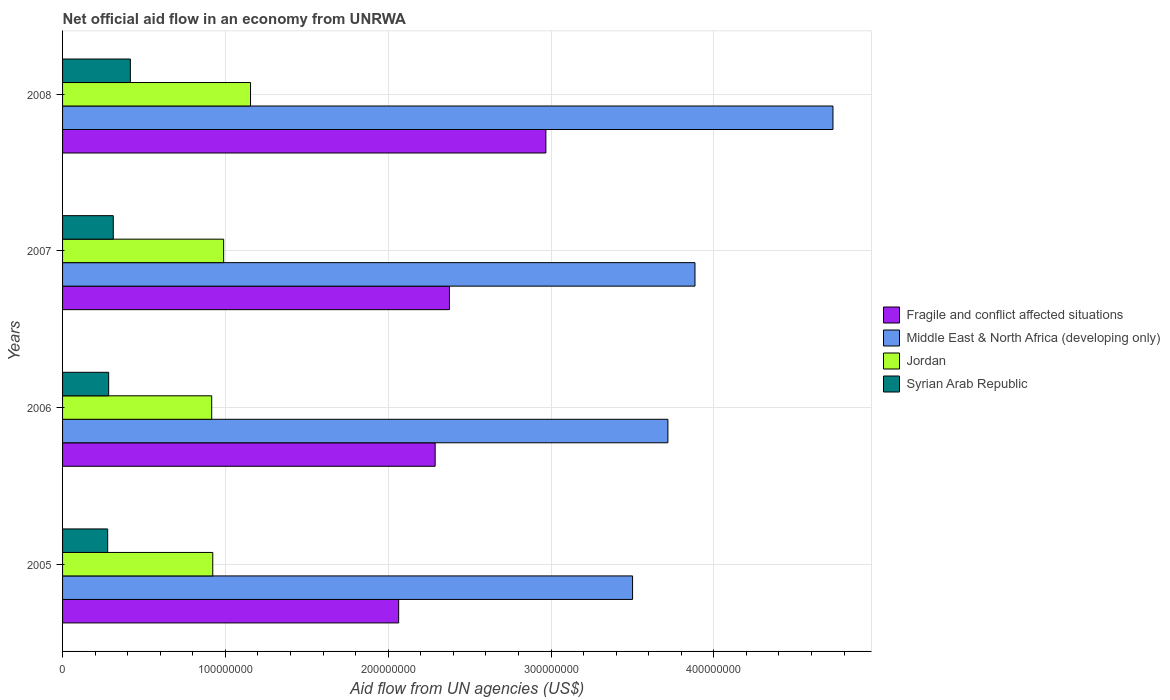How many different coloured bars are there?
Keep it short and to the point. 4. How many groups of bars are there?
Provide a succinct answer. 4. How many bars are there on the 2nd tick from the top?
Ensure brevity in your answer.  4. In how many cases, is the number of bars for a given year not equal to the number of legend labels?
Offer a terse response. 0. What is the net official aid flow in Jordan in 2006?
Give a very brief answer. 9.16e+07. Across all years, what is the maximum net official aid flow in Middle East & North Africa (developing only)?
Offer a terse response. 4.73e+08. Across all years, what is the minimum net official aid flow in Middle East & North Africa (developing only)?
Your answer should be compact. 3.50e+08. What is the total net official aid flow in Jordan in the graph?
Provide a succinct answer. 3.98e+08. What is the difference between the net official aid flow in Syrian Arab Republic in 2006 and that in 2007?
Your response must be concise. -2.83e+06. What is the difference between the net official aid flow in Syrian Arab Republic in 2005 and the net official aid flow in Middle East & North Africa (developing only) in 2007?
Ensure brevity in your answer.  -3.61e+08. What is the average net official aid flow in Syrian Arab Republic per year?
Offer a terse response. 3.22e+07. In the year 2008, what is the difference between the net official aid flow in Syrian Arab Republic and net official aid flow in Jordan?
Your response must be concise. -7.38e+07. In how many years, is the net official aid flow in Syrian Arab Republic greater than 140000000 US$?
Offer a very short reply. 0. What is the ratio of the net official aid flow in Fragile and conflict affected situations in 2007 to that in 2008?
Provide a short and direct response. 0.8. Is the difference between the net official aid flow in Syrian Arab Republic in 2005 and 2006 greater than the difference between the net official aid flow in Jordan in 2005 and 2006?
Keep it short and to the point. No. What is the difference between the highest and the second highest net official aid flow in Middle East & North Africa (developing only)?
Give a very brief answer. 8.48e+07. What is the difference between the highest and the lowest net official aid flow in Fragile and conflict affected situations?
Your answer should be compact. 9.04e+07. What does the 3rd bar from the top in 2005 represents?
Keep it short and to the point. Middle East & North Africa (developing only). What does the 2nd bar from the bottom in 2006 represents?
Make the answer very short. Middle East & North Africa (developing only). Are all the bars in the graph horizontal?
Provide a short and direct response. Yes. How many years are there in the graph?
Your answer should be very brief. 4. Are the values on the major ticks of X-axis written in scientific E-notation?
Your answer should be very brief. No. Does the graph contain any zero values?
Ensure brevity in your answer.  No. How many legend labels are there?
Provide a succinct answer. 4. What is the title of the graph?
Give a very brief answer. Net official aid flow in an economy from UNRWA. What is the label or title of the X-axis?
Provide a succinct answer. Aid flow from UN agencies (US$). What is the label or title of the Y-axis?
Provide a short and direct response. Years. What is the Aid flow from UN agencies (US$) in Fragile and conflict affected situations in 2005?
Offer a very short reply. 2.06e+08. What is the Aid flow from UN agencies (US$) of Middle East & North Africa (developing only) in 2005?
Give a very brief answer. 3.50e+08. What is the Aid flow from UN agencies (US$) in Jordan in 2005?
Offer a very short reply. 9.22e+07. What is the Aid flow from UN agencies (US$) of Syrian Arab Republic in 2005?
Give a very brief answer. 2.77e+07. What is the Aid flow from UN agencies (US$) of Fragile and conflict affected situations in 2006?
Provide a short and direct response. 2.29e+08. What is the Aid flow from UN agencies (US$) in Middle East & North Africa (developing only) in 2006?
Ensure brevity in your answer.  3.72e+08. What is the Aid flow from UN agencies (US$) of Jordan in 2006?
Your answer should be compact. 9.16e+07. What is the Aid flow from UN agencies (US$) in Syrian Arab Republic in 2006?
Keep it short and to the point. 2.83e+07. What is the Aid flow from UN agencies (US$) of Fragile and conflict affected situations in 2007?
Offer a terse response. 2.38e+08. What is the Aid flow from UN agencies (US$) in Middle East & North Africa (developing only) in 2007?
Provide a succinct answer. 3.88e+08. What is the Aid flow from UN agencies (US$) in Jordan in 2007?
Provide a short and direct response. 9.89e+07. What is the Aid flow from UN agencies (US$) of Syrian Arab Republic in 2007?
Make the answer very short. 3.12e+07. What is the Aid flow from UN agencies (US$) in Fragile and conflict affected situations in 2008?
Keep it short and to the point. 2.97e+08. What is the Aid flow from UN agencies (US$) of Middle East & North Africa (developing only) in 2008?
Offer a very short reply. 4.73e+08. What is the Aid flow from UN agencies (US$) of Jordan in 2008?
Give a very brief answer. 1.15e+08. What is the Aid flow from UN agencies (US$) in Syrian Arab Republic in 2008?
Your answer should be compact. 4.16e+07. Across all years, what is the maximum Aid flow from UN agencies (US$) of Fragile and conflict affected situations?
Your answer should be compact. 2.97e+08. Across all years, what is the maximum Aid flow from UN agencies (US$) in Middle East & North Africa (developing only)?
Keep it short and to the point. 4.73e+08. Across all years, what is the maximum Aid flow from UN agencies (US$) in Jordan?
Provide a short and direct response. 1.15e+08. Across all years, what is the maximum Aid flow from UN agencies (US$) of Syrian Arab Republic?
Your answer should be compact. 4.16e+07. Across all years, what is the minimum Aid flow from UN agencies (US$) in Fragile and conflict affected situations?
Keep it short and to the point. 2.06e+08. Across all years, what is the minimum Aid flow from UN agencies (US$) in Middle East & North Africa (developing only)?
Keep it short and to the point. 3.50e+08. Across all years, what is the minimum Aid flow from UN agencies (US$) of Jordan?
Offer a terse response. 9.16e+07. Across all years, what is the minimum Aid flow from UN agencies (US$) in Syrian Arab Republic?
Your response must be concise. 2.77e+07. What is the total Aid flow from UN agencies (US$) of Fragile and conflict affected situations in the graph?
Provide a succinct answer. 9.70e+08. What is the total Aid flow from UN agencies (US$) in Middle East & North Africa (developing only) in the graph?
Offer a very short reply. 1.58e+09. What is the total Aid flow from UN agencies (US$) in Jordan in the graph?
Offer a very short reply. 3.98e+08. What is the total Aid flow from UN agencies (US$) in Syrian Arab Republic in the graph?
Your response must be concise. 1.29e+08. What is the difference between the Aid flow from UN agencies (US$) of Fragile and conflict affected situations in 2005 and that in 2006?
Make the answer very short. -2.24e+07. What is the difference between the Aid flow from UN agencies (US$) of Middle East & North Africa (developing only) in 2005 and that in 2006?
Offer a very short reply. -2.17e+07. What is the difference between the Aid flow from UN agencies (US$) of Jordan in 2005 and that in 2006?
Give a very brief answer. 6.50e+05. What is the difference between the Aid flow from UN agencies (US$) in Syrian Arab Republic in 2005 and that in 2006?
Your response must be concise. -6.10e+05. What is the difference between the Aid flow from UN agencies (US$) of Fragile and conflict affected situations in 2005 and that in 2007?
Ensure brevity in your answer.  -3.12e+07. What is the difference between the Aid flow from UN agencies (US$) of Middle East & North Africa (developing only) in 2005 and that in 2007?
Your answer should be compact. -3.83e+07. What is the difference between the Aid flow from UN agencies (US$) in Jordan in 2005 and that in 2007?
Offer a terse response. -6.68e+06. What is the difference between the Aid flow from UN agencies (US$) in Syrian Arab Republic in 2005 and that in 2007?
Your answer should be very brief. -3.44e+06. What is the difference between the Aid flow from UN agencies (US$) in Fragile and conflict affected situations in 2005 and that in 2008?
Give a very brief answer. -9.04e+07. What is the difference between the Aid flow from UN agencies (US$) of Middle East & North Africa (developing only) in 2005 and that in 2008?
Offer a very short reply. -1.23e+08. What is the difference between the Aid flow from UN agencies (US$) of Jordan in 2005 and that in 2008?
Ensure brevity in your answer.  -2.32e+07. What is the difference between the Aid flow from UN agencies (US$) in Syrian Arab Republic in 2005 and that in 2008?
Provide a short and direct response. -1.39e+07. What is the difference between the Aid flow from UN agencies (US$) of Fragile and conflict affected situations in 2006 and that in 2007?
Offer a terse response. -8.77e+06. What is the difference between the Aid flow from UN agencies (US$) of Middle East & North Africa (developing only) in 2006 and that in 2007?
Ensure brevity in your answer.  -1.66e+07. What is the difference between the Aid flow from UN agencies (US$) in Jordan in 2006 and that in 2007?
Give a very brief answer. -7.33e+06. What is the difference between the Aid flow from UN agencies (US$) of Syrian Arab Republic in 2006 and that in 2007?
Your answer should be very brief. -2.83e+06. What is the difference between the Aid flow from UN agencies (US$) in Fragile and conflict affected situations in 2006 and that in 2008?
Your answer should be very brief. -6.80e+07. What is the difference between the Aid flow from UN agencies (US$) of Middle East & North Africa (developing only) in 2006 and that in 2008?
Offer a very short reply. -1.01e+08. What is the difference between the Aid flow from UN agencies (US$) in Jordan in 2006 and that in 2008?
Offer a very short reply. -2.38e+07. What is the difference between the Aid flow from UN agencies (US$) of Syrian Arab Republic in 2006 and that in 2008?
Keep it short and to the point. -1.33e+07. What is the difference between the Aid flow from UN agencies (US$) in Fragile and conflict affected situations in 2007 and that in 2008?
Your answer should be very brief. -5.92e+07. What is the difference between the Aid flow from UN agencies (US$) in Middle East & North Africa (developing only) in 2007 and that in 2008?
Your answer should be compact. -8.48e+07. What is the difference between the Aid flow from UN agencies (US$) of Jordan in 2007 and that in 2008?
Your answer should be compact. -1.65e+07. What is the difference between the Aid flow from UN agencies (US$) in Syrian Arab Republic in 2007 and that in 2008?
Offer a very short reply. -1.05e+07. What is the difference between the Aid flow from UN agencies (US$) of Fragile and conflict affected situations in 2005 and the Aid flow from UN agencies (US$) of Middle East & North Africa (developing only) in 2006?
Your response must be concise. -1.65e+08. What is the difference between the Aid flow from UN agencies (US$) in Fragile and conflict affected situations in 2005 and the Aid flow from UN agencies (US$) in Jordan in 2006?
Your response must be concise. 1.15e+08. What is the difference between the Aid flow from UN agencies (US$) of Fragile and conflict affected situations in 2005 and the Aid flow from UN agencies (US$) of Syrian Arab Republic in 2006?
Make the answer very short. 1.78e+08. What is the difference between the Aid flow from UN agencies (US$) in Middle East & North Africa (developing only) in 2005 and the Aid flow from UN agencies (US$) in Jordan in 2006?
Keep it short and to the point. 2.59e+08. What is the difference between the Aid flow from UN agencies (US$) of Middle East & North Africa (developing only) in 2005 and the Aid flow from UN agencies (US$) of Syrian Arab Republic in 2006?
Your response must be concise. 3.22e+08. What is the difference between the Aid flow from UN agencies (US$) in Jordan in 2005 and the Aid flow from UN agencies (US$) in Syrian Arab Republic in 2006?
Your answer should be compact. 6.39e+07. What is the difference between the Aid flow from UN agencies (US$) of Fragile and conflict affected situations in 2005 and the Aid flow from UN agencies (US$) of Middle East & North Africa (developing only) in 2007?
Provide a short and direct response. -1.82e+08. What is the difference between the Aid flow from UN agencies (US$) of Fragile and conflict affected situations in 2005 and the Aid flow from UN agencies (US$) of Jordan in 2007?
Offer a very short reply. 1.08e+08. What is the difference between the Aid flow from UN agencies (US$) in Fragile and conflict affected situations in 2005 and the Aid flow from UN agencies (US$) in Syrian Arab Republic in 2007?
Your response must be concise. 1.75e+08. What is the difference between the Aid flow from UN agencies (US$) of Middle East & North Africa (developing only) in 2005 and the Aid flow from UN agencies (US$) of Jordan in 2007?
Your answer should be very brief. 2.51e+08. What is the difference between the Aid flow from UN agencies (US$) of Middle East & North Africa (developing only) in 2005 and the Aid flow from UN agencies (US$) of Syrian Arab Republic in 2007?
Offer a very short reply. 3.19e+08. What is the difference between the Aid flow from UN agencies (US$) in Jordan in 2005 and the Aid flow from UN agencies (US$) in Syrian Arab Republic in 2007?
Provide a short and direct response. 6.11e+07. What is the difference between the Aid flow from UN agencies (US$) of Fragile and conflict affected situations in 2005 and the Aid flow from UN agencies (US$) of Middle East & North Africa (developing only) in 2008?
Your answer should be very brief. -2.67e+08. What is the difference between the Aid flow from UN agencies (US$) in Fragile and conflict affected situations in 2005 and the Aid flow from UN agencies (US$) in Jordan in 2008?
Your response must be concise. 9.10e+07. What is the difference between the Aid flow from UN agencies (US$) of Fragile and conflict affected situations in 2005 and the Aid flow from UN agencies (US$) of Syrian Arab Republic in 2008?
Your response must be concise. 1.65e+08. What is the difference between the Aid flow from UN agencies (US$) in Middle East & North Africa (developing only) in 2005 and the Aid flow from UN agencies (US$) in Jordan in 2008?
Your answer should be very brief. 2.35e+08. What is the difference between the Aid flow from UN agencies (US$) of Middle East & North Africa (developing only) in 2005 and the Aid flow from UN agencies (US$) of Syrian Arab Republic in 2008?
Keep it short and to the point. 3.08e+08. What is the difference between the Aid flow from UN agencies (US$) of Jordan in 2005 and the Aid flow from UN agencies (US$) of Syrian Arab Republic in 2008?
Ensure brevity in your answer.  5.06e+07. What is the difference between the Aid flow from UN agencies (US$) in Fragile and conflict affected situations in 2006 and the Aid flow from UN agencies (US$) in Middle East & North Africa (developing only) in 2007?
Offer a terse response. -1.60e+08. What is the difference between the Aid flow from UN agencies (US$) of Fragile and conflict affected situations in 2006 and the Aid flow from UN agencies (US$) of Jordan in 2007?
Make the answer very short. 1.30e+08. What is the difference between the Aid flow from UN agencies (US$) in Fragile and conflict affected situations in 2006 and the Aid flow from UN agencies (US$) in Syrian Arab Republic in 2007?
Make the answer very short. 1.98e+08. What is the difference between the Aid flow from UN agencies (US$) of Middle East & North Africa (developing only) in 2006 and the Aid flow from UN agencies (US$) of Jordan in 2007?
Your answer should be very brief. 2.73e+08. What is the difference between the Aid flow from UN agencies (US$) of Middle East & North Africa (developing only) in 2006 and the Aid flow from UN agencies (US$) of Syrian Arab Republic in 2007?
Your response must be concise. 3.41e+08. What is the difference between the Aid flow from UN agencies (US$) of Jordan in 2006 and the Aid flow from UN agencies (US$) of Syrian Arab Republic in 2007?
Provide a succinct answer. 6.04e+07. What is the difference between the Aid flow from UN agencies (US$) in Fragile and conflict affected situations in 2006 and the Aid flow from UN agencies (US$) in Middle East & North Africa (developing only) in 2008?
Offer a very short reply. -2.44e+08. What is the difference between the Aid flow from UN agencies (US$) of Fragile and conflict affected situations in 2006 and the Aid flow from UN agencies (US$) of Jordan in 2008?
Offer a terse response. 1.13e+08. What is the difference between the Aid flow from UN agencies (US$) in Fragile and conflict affected situations in 2006 and the Aid flow from UN agencies (US$) in Syrian Arab Republic in 2008?
Give a very brief answer. 1.87e+08. What is the difference between the Aid flow from UN agencies (US$) of Middle East & North Africa (developing only) in 2006 and the Aid flow from UN agencies (US$) of Jordan in 2008?
Give a very brief answer. 2.56e+08. What is the difference between the Aid flow from UN agencies (US$) in Middle East & North Africa (developing only) in 2006 and the Aid flow from UN agencies (US$) in Syrian Arab Republic in 2008?
Keep it short and to the point. 3.30e+08. What is the difference between the Aid flow from UN agencies (US$) of Jordan in 2006 and the Aid flow from UN agencies (US$) of Syrian Arab Republic in 2008?
Your response must be concise. 5.00e+07. What is the difference between the Aid flow from UN agencies (US$) of Fragile and conflict affected situations in 2007 and the Aid flow from UN agencies (US$) of Middle East & North Africa (developing only) in 2008?
Keep it short and to the point. -2.36e+08. What is the difference between the Aid flow from UN agencies (US$) of Fragile and conflict affected situations in 2007 and the Aid flow from UN agencies (US$) of Jordan in 2008?
Make the answer very short. 1.22e+08. What is the difference between the Aid flow from UN agencies (US$) of Fragile and conflict affected situations in 2007 and the Aid flow from UN agencies (US$) of Syrian Arab Republic in 2008?
Offer a terse response. 1.96e+08. What is the difference between the Aid flow from UN agencies (US$) in Middle East & North Africa (developing only) in 2007 and the Aid flow from UN agencies (US$) in Jordan in 2008?
Your answer should be compact. 2.73e+08. What is the difference between the Aid flow from UN agencies (US$) in Middle East & North Africa (developing only) in 2007 and the Aid flow from UN agencies (US$) in Syrian Arab Republic in 2008?
Ensure brevity in your answer.  3.47e+08. What is the difference between the Aid flow from UN agencies (US$) in Jordan in 2007 and the Aid flow from UN agencies (US$) in Syrian Arab Republic in 2008?
Your response must be concise. 5.73e+07. What is the average Aid flow from UN agencies (US$) of Fragile and conflict affected situations per year?
Ensure brevity in your answer.  2.42e+08. What is the average Aid flow from UN agencies (US$) of Middle East & North Africa (developing only) per year?
Offer a terse response. 3.96e+08. What is the average Aid flow from UN agencies (US$) of Jordan per year?
Give a very brief answer. 9.96e+07. What is the average Aid flow from UN agencies (US$) in Syrian Arab Republic per year?
Give a very brief answer. 3.22e+07. In the year 2005, what is the difference between the Aid flow from UN agencies (US$) of Fragile and conflict affected situations and Aid flow from UN agencies (US$) of Middle East & North Africa (developing only)?
Provide a succinct answer. -1.44e+08. In the year 2005, what is the difference between the Aid flow from UN agencies (US$) of Fragile and conflict affected situations and Aid flow from UN agencies (US$) of Jordan?
Your response must be concise. 1.14e+08. In the year 2005, what is the difference between the Aid flow from UN agencies (US$) in Fragile and conflict affected situations and Aid flow from UN agencies (US$) in Syrian Arab Republic?
Offer a very short reply. 1.79e+08. In the year 2005, what is the difference between the Aid flow from UN agencies (US$) in Middle East & North Africa (developing only) and Aid flow from UN agencies (US$) in Jordan?
Give a very brief answer. 2.58e+08. In the year 2005, what is the difference between the Aid flow from UN agencies (US$) in Middle East & North Africa (developing only) and Aid flow from UN agencies (US$) in Syrian Arab Republic?
Make the answer very short. 3.22e+08. In the year 2005, what is the difference between the Aid flow from UN agencies (US$) in Jordan and Aid flow from UN agencies (US$) in Syrian Arab Republic?
Your response must be concise. 6.45e+07. In the year 2006, what is the difference between the Aid flow from UN agencies (US$) in Fragile and conflict affected situations and Aid flow from UN agencies (US$) in Middle East & North Africa (developing only)?
Make the answer very short. -1.43e+08. In the year 2006, what is the difference between the Aid flow from UN agencies (US$) of Fragile and conflict affected situations and Aid flow from UN agencies (US$) of Jordan?
Keep it short and to the point. 1.37e+08. In the year 2006, what is the difference between the Aid flow from UN agencies (US$) in Fragile and conflict affected situations and Aid flow from UN agencies (US$) in Syrian Arab Republic?
Give a very brief answer. 2.01e+08. In the year 2006, what is the difference between the Aid flow from UN agencies (US$) of Middle East & North Africa (developing only) and Aid flow from UN agencies (US$) of Jordan?
Offer a very short reply. 2.80e+08. In the year 2006, what is the difference between the Aid flow from UN agencies (US$) of Middle East & North Africa (developing only) and Aid flow from UN agencies (US$) of Syrian Arab Republic?
Your response must be concise. 3.43e+08. In the year 2006, what is the difference between the Aid flow from UN agencies (US$) in Jordan and Aid flow from UN agencies (US$) in Syrian Arab Republic?
Provide a short and direct response. 6.33e+07. In the year 2007, what is the difference between the Aid flow from UN agencies (US$) of Fragile and conflict affected situations and Aid flow from UN agencies (US$) of Middle East & North Africa (developing only)?
Make the answer very short. -1.51e+08. In the year 2007, what is the difference between the Aid flow from UN agencies (US$) in Fragile and conflict affected situations and Aid flow from UN agencies (US$) in Jordan?
Offer a very short reply. 1.39e+08. In the year 2007, what is the difference between the Aid flow from UN agencies (US$) in Fragile and conflict affected situations and Aid flow from UN agencies (US$) in Syrian Arab Republic?
Offer a terse response. 2.06e+08. In the year 2007, what is the difference between the Aid flow from UN agencies (US$) of Middle East & North Africa (developing only) and Aid flow from UN agencies (US$) of Jordan?
Make the answer very short. 2.90e+08. In the year 2007, what is the difference between the Aid flow from UN agencies (US$) of Middle East & North Africa (developing only) and Aid flow from UN agencies (US$) of Syrian Arab Republic?
Your answer should be very brief. 3.57e+08. In the year 2007, what is the difference between the Aid flow from UN agencies (US$) in Jordan and Aid flow from UN agencies (US$) in Syrian Arab Republic?
Provide a succinct answer. 6.78e+07. In the year 2008, what is the difference between the Aid flow from UN agencies (US$) of Fragile and conflict affected situations and Aid flow from UN agencies (US$) of Middle East & North Africa (developing only)?
Offer a very short reply. -1.76e+08. In the year 2008, what is the difference between the Aid flow from UN agencies (US$) in Fragile and conflict affected situations and Aid flow from UN agencies (US$) in Jordan?
Ensure brevity in your answer.  1.81e+08. In the year 2008, what is the difference between the Aid flow from UN agencies (US$) in Fragile and conflict affected situations and Aid flow from UN agencies (US$) in Syrian Arab Republic?
Your answer should be very brief. 2.55e+08. In the year 2008, what is the difference between the Aid flow from UN agencies (US$) in Middle East & North Africa (developing only) and Aid flow from UN agencies (US$) in Jordan?
Your answer should be very brief. 3.58e+08. In the year 2008, what is the difference between the Aid flow from UN agencies (US$) of Middle East & North Africa (developing only) and Aid flow from UN agencies (US$) of Syrian Arab Republic?
Make the answer very short. 4.32e+08. In the year 2008, what is the difference between the Aid flow from UN agencies (US$) in Jordan and Aid flow from UN agencies (US$) in Syrian Arab Republic?
Ensure brevity in your answer.  7.38e+07. What is the ratio of the Aid flow from UN agencies (US$) in Fragile and conflict affected situations in 2005 to that in 2006?
Give a very brief answer. 0.9. What is the ratio of the Aid flow from UN agencies (US$) in Middle East & North Africa (developing only) in 2005 to that in 2006?
Offer a very short reply. 0.94. What is the ratio of the Aid flow from UN agencies (US$) in Jordan in 2005 to that in 2006?
Your answer should be very brief. 1.01. What is the ratio of the Aid flow from UN agencies (US$) of Syrian Arab Republic in 2005 to that in 2006?
Your response must be concise. 0.98. What is the ratio of the Aid flow from UN agencies (US$) of Fragile and conflict affected situations in 2005 to that in 2007?
Your answer should be very brief. 0.87. What is the ratio of the Aid flow from UN agencies (US$) in Middle East & North Africa (developing only) in 2005 to that in 2007?
Offer a very short reply. 0.9. What is the ratio of the Aid flow from UN agencies (US$) in Jordan in 2005 to that in 2007?
Your answer should be very brief. 0.93. What is the ratio of the Aid flow from UN agencies (US$) of Syrian Arab Republic in 2005 to that in 2007?
Your answer should be compact. 0.89. What is the ratio of the Aid flow from UN agencies (US$) of Fragile and conflict affected situations in 2005 to that in 2008?
Provide a succinct answer. 0.7. What is the ratio of the Aid flow from UN agencies (US$) in Middle East & North Africa (developing only) in 2005 to that in 2008?
Make the answer very short. 0.74. What is the ratio of the Aid flow from UN agencies (US$) in Jordan in 2005 to that in 2008?
Ensure brevity in your answer.  0.8. What is the ratio of the Aid flow from UN agencies (US$) in Syrian Arab Republic in 2005 to that in 2008?
Give a very brief answer. 0.67. What is the ratio of the Aid flow from UN agencies (US$) in Fragile and conflict affected situations in 2006 to that in 2007?
Ensure brevity in your answer.  0.96. What is the ratio of the Aid flow from UN agencies (US$) of Middle East & North Africa (developing only) in 2006 to that in 2007?
Keep it short and to the point. 0.96. What is the ratio of the Aid flow from UN agencies (US$) of Jordan in 2006 to that in 2007?
Make the answer very short. 0.93. What is the ratio of the Aid flow from UN agencies (US$) in Syrian Arab Republic in 2006 to that in 2007?
Offer a terse response. 0.91. What is the ratio of the Aid flow from UN agencies (US$) in Fragile and conflict affected situations in 2006 to that in 2008?
Make the answer very short. 0.77. What is the ratio of the Aid flow from UN agencies (US$) of Middle East & North Africa (developing only) in 2006 to that in 2008?
Offer a terse response. 0.79. What is the ratio of the Aid flow from UN agencies (US$) in Jordan in 2006 to that in 2008?
Offer a very short reply. 0.79. What is the ratio of the Aid flow from UN agencies (US$) in Syrian Arab Republic in 2006 to that in 2008?
Your response must be concise. 0.68. What is the ratio of the Aid flow from UN agencies (US$) of Fragile and conflict affected situations in 2007 to that in 2008?
Keep it short and to the point. 0.8. What is the ratio of the Aid flow from UN agencies (US$) in Middle East & North Africa (developing only) in 2007 to that in 2008?
Keep it short and to the point. 0.82. What is the ratio of the Aid flow from UN agencies (US$) in Jordan in 2007 to that in 2008?
Ensure brevity in your answer.  0.86. What is the ratio of the Aid flow from UN agencies (US$) of Syrian Arab Republic in 2007 to that in 2008?
Ensure brevity in your answer.  0.75. What is the difference between the highest and the second highest Aid flow from UN agencies (US$) of Fragile and conflict affected situations?
Your answer should be compact. 5.92e+07. What is the difference between the highest and the second highest Aid flow from UN agencies (US$) of Middle East & North Africa (developing only)?
Your answer should be compact. 8.48e+07. What is the difference between the highest and the second highest Aid flow from UN agencies (US$) in Jordan?
Provide a short and direct response. 1.65e+07. What is the difference between the highest and the second highest Aid flow from UN agencies (US$) in Syrian Arab Republic?
Offer a very short reply. 1.05e+07. What is the difference between the highest and the lowest Aid flow from UN agencies (US$) in Fragile and conflict affected situations?
Offer a terse response. 9.04e+07. What is the difference between the highest and the lowest Aid flow from UN agencies (US$) of Middle East & North Africa (developing only)?
Provide a short and direct response. 1.23e+08. What is the difference between the highest and the lowest Aid flow from UN agencies (US$) in Jordan?
Make the answer very short. 2.38e+07. What is the difference between the highest and the lowest Aid flow from UN agencies (US$) in Syrian Arab Republic?
Offer a very short reply. 1.39e+07. 